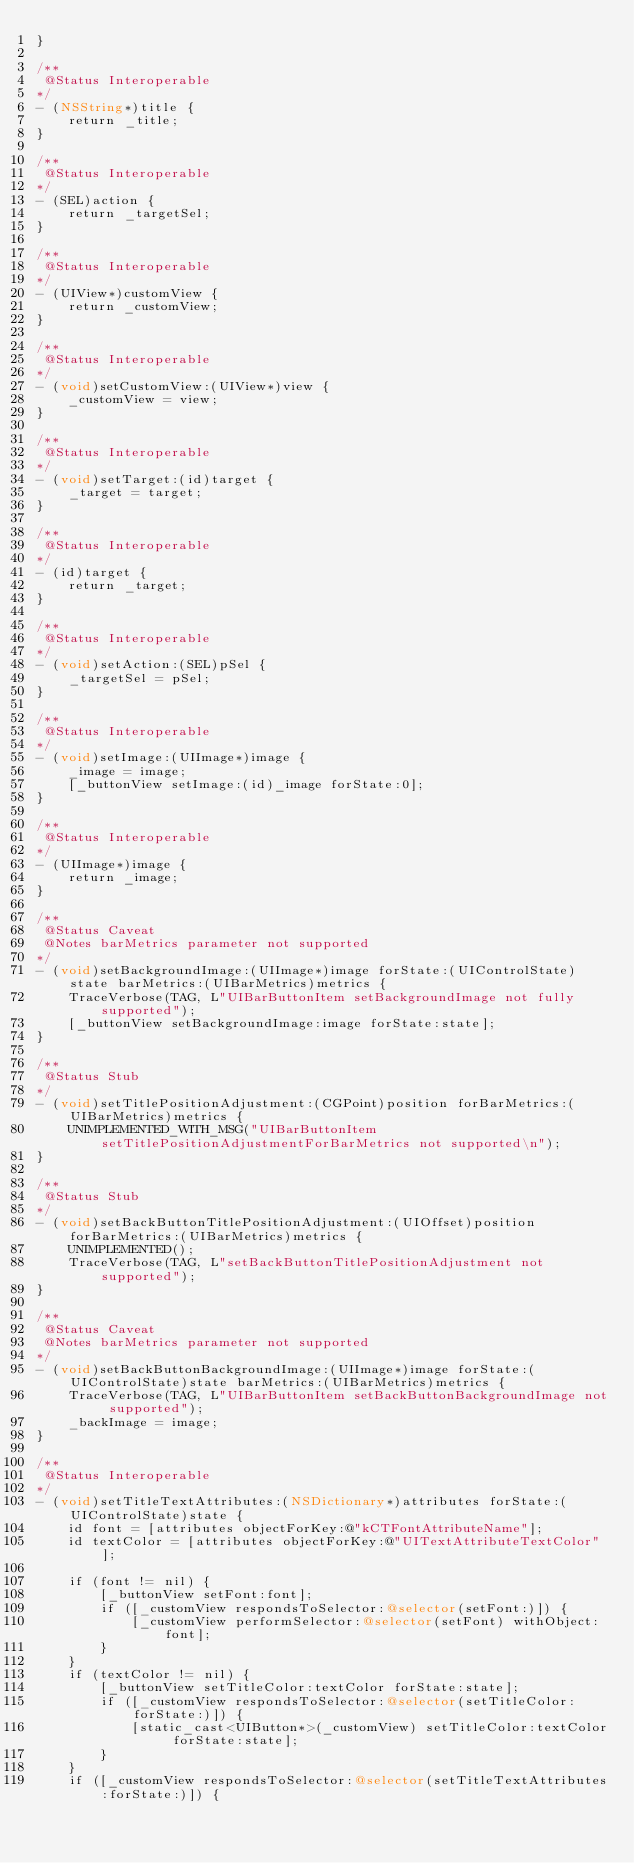Convert code to text. <code><loc_0><loc_0><loc_500><loc_500><_ObjectiveC_>}

/**
 @Status Interoperable
*/
- (NSString*)title {
    return _title;
}

/**
 @Status Interoperable
*/
- (SEL)action {
    return _targetSel;
}

/**
 @Status Interoperable
*/
- (UIView*)customView {
    return _customView;
}

/**
 @Status Interoperable
*/
- (void)setCustomView:(UIView*)view {
    _customView = view;
}

/**
 @Status Interoperable
*/
- (void)setTarget:(id)target {
    _target = target;
}

/**
 @Status Interoperable
*/
- (id)target {
    return _target;
}

/**
 @Status Interoperable
*/
- (void)setAction:(SEL)pSel {
    _targetSel = pSel;
}

/**
 @Status Interoperable
*/
- (void)setImage:(UIImage*)image {
    _image = image;
    [_buttonView setImage:(id)_image forState:0];
}

/**
 @Status Interoperable
*/
- (UIImage*)image {
    return _image;
}

/**
 @Status Caveat
 @Notes barMetrics parameter not supported
*/
- (void)setBackgroundImage:(UIImage*)image forState:(UIControlState)state barMetrics:(UIBarMetrics)metrics {
    TraceVerbose(TAG, L"UIBarButtonItem setBackgroundImage not fully supported");
    [_buttonView setBackgroundImage:image forState:state];
}

/**
 @Status Stub
*/
- (void)setTitlePositionAdjustment:(CGPoint)position forBarMetrics:(UIBarMetrics)metrics {
    UNIMPLEMENTED_WITH_MSG("UIBarButtonItem setTitlePositionAdjustmentForBarMetrics not supported\n");
}

/**
 @Status Stub
*/
- (void)setBackButtonTitlePositionAdjustment:(UIOffset)position forBarMetrics:(UIBarMetrics)metrics {
    UNIMPLEMENTED();
    TraceVerbose(TAG, L"setBackButtonTitlePositionAdjustment not supported");
}

/**
 @Status Caveat
 @Notes barMetrics parameter not supported
*/
- (void)setBackButtonBackgroundImage:(UIImage*)image forState:(UIControlState)state barMetrics:(UIBarMetrics)metrics {
    TraceVerbose(TAG, L"UIBarButtonItem setBackButtonBackgroundImage not supported");
    _backImage = image;
}

/**
 @Status Interoperable
*/
- (void)setTitleTextAttributes:(NSDictionary*)attributes forState:(UIControlState)state {
    id font = [attributes objectForKey:@"kCTFontAttributeName"];
    id textColor = [attributes objectForKey:@"UITextAttributeTextColor"];

    if (font != nil) {
        [_buttonView setFont:font];
        if ([_customView respondsToSelector:@selector(setFont:)]) {
            [_customView performSelector:@selector(setFont) withObject:font];
        }
    }
    if (textColor != nil) {
        [_buttonView setTitleColor:textColor forState:state];
        if ([_customView respondsToSelector:@selector(setTitleColor:forState:)]) {
            [static_cast<UIButton*>(_customView) setTitleColor:textColor forState:state];
        }
    }
    if ([_customView respondsToSelector:@selector(setTitleTextAttributes:forState:)]) {</code> 